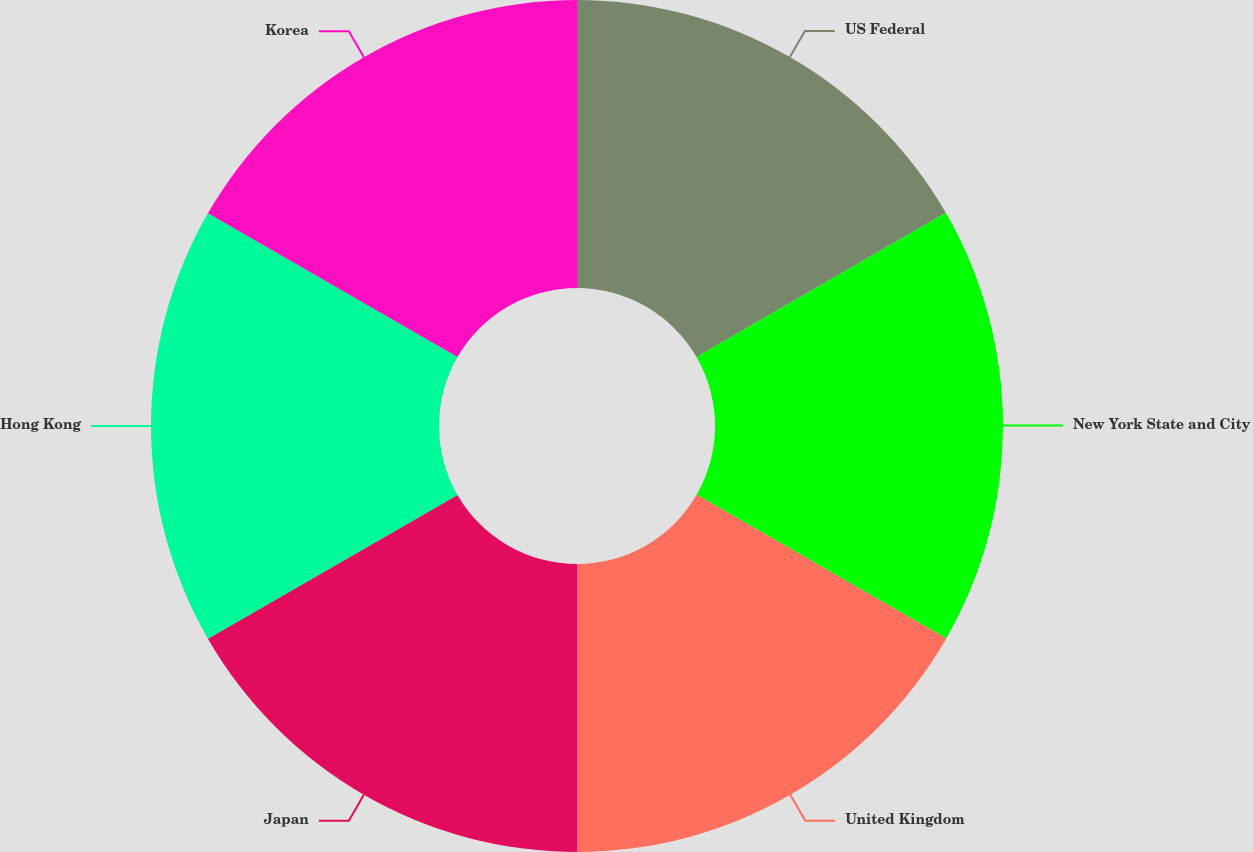Convert chart. <chart><loc_0><loc_0><loc_500><loc_500><pie_chart><fcel>US Federal<fcel>New York State and City<fcel>United Kingdom<fcel>Japan<fcel>Hong Kong<fcel>Korea<nl><fcel>16.66%<fcel>16.65%<fcel>16.69%<fcel>16.68%<fcel>16.64%<fcel>16.68%<nl></chart> 